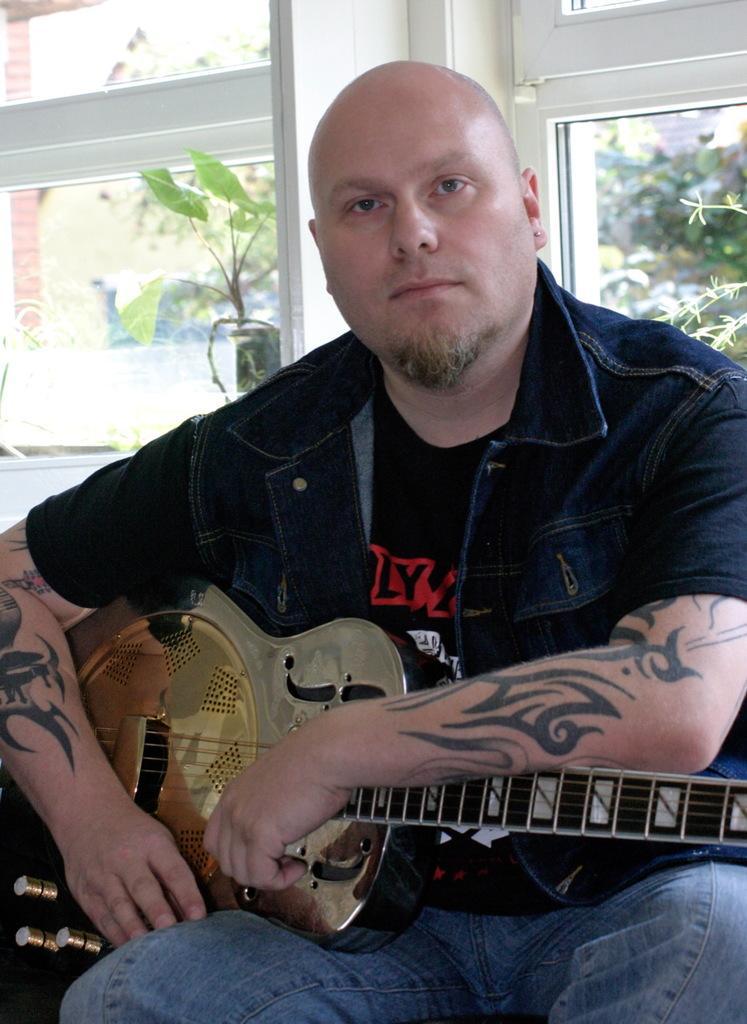Please provide a concise description of this image. In this image there is a person sitting and holding a guitar and at back ground there is plant , tree, window. 